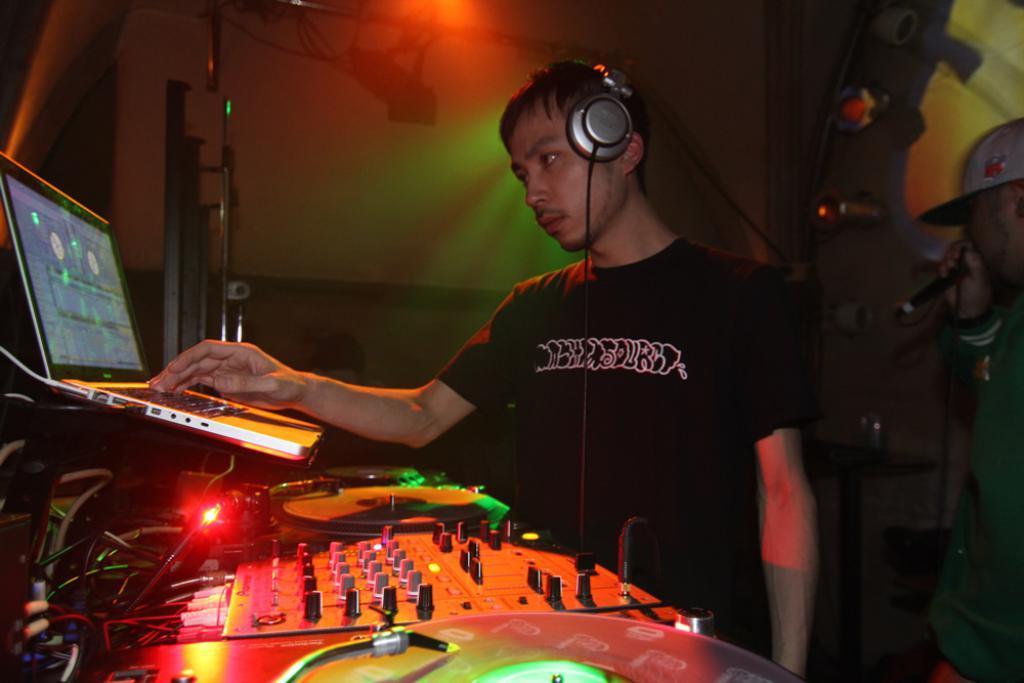In one or two sentences, can you explain what this image depicts? In this image a man wearing black t-shirt is wearing a headphone. In the right a man wearing green jacket and cap is holding a mic. The person is using laptop. There are disc, switch board in front of him. On the top there are lights. 